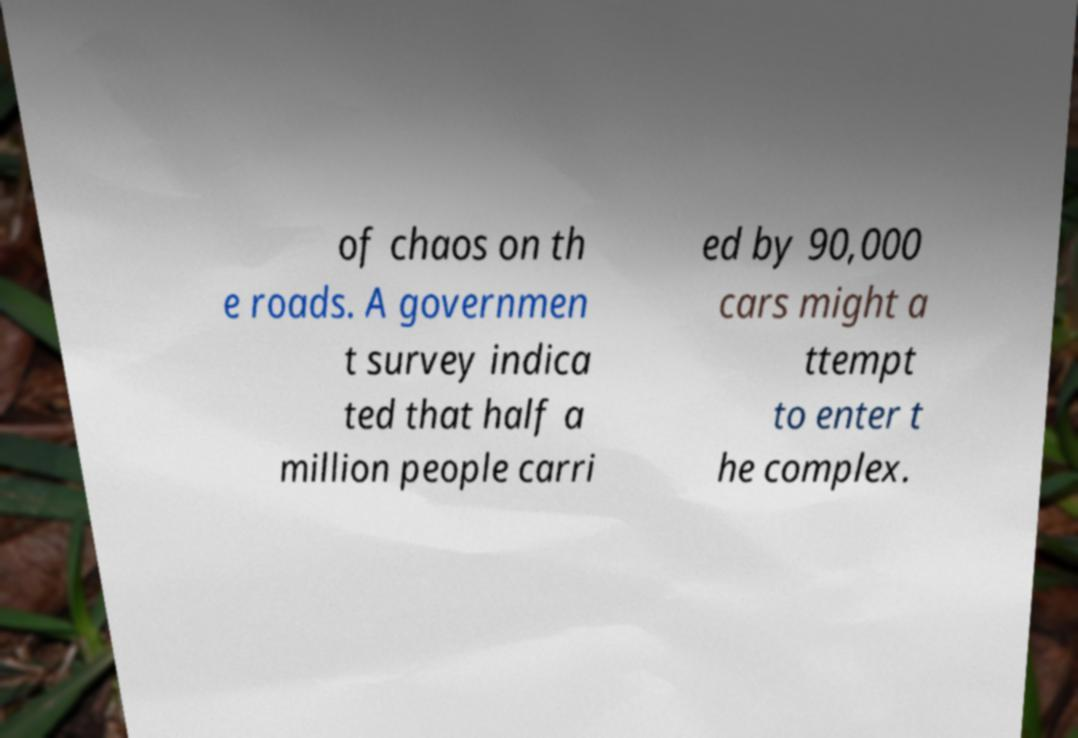I need the written content from this picture converted into text. Can you do that? of chaos on th e roads. A governmen t survey indica ted that half a million people carri ed by 90,000 cars might a ttempt to enter t he complex. 